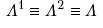<formula> <loc_0><loc_0><loc_500><loc_500>\Lambda ^ { 1 } \equiv \Lambda ^ { 2 } \equiv \Lambda \\</formula> 